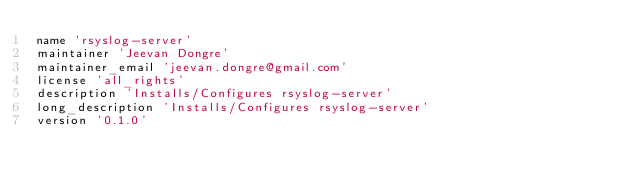<code> <loc_0><loc_0><loc_500><loc_500><_Ruby_>name 'rsyslog-server'
maintainer 'Jeevan Dongre'
maintainer_email 'jeevan.dongre@gmail.com'
license 'all_rights'
description 'Installs/Configures rsyslog-server'
long_description 'Installs/Configures rsyslog-server'
version '0.1.0'
</code> 